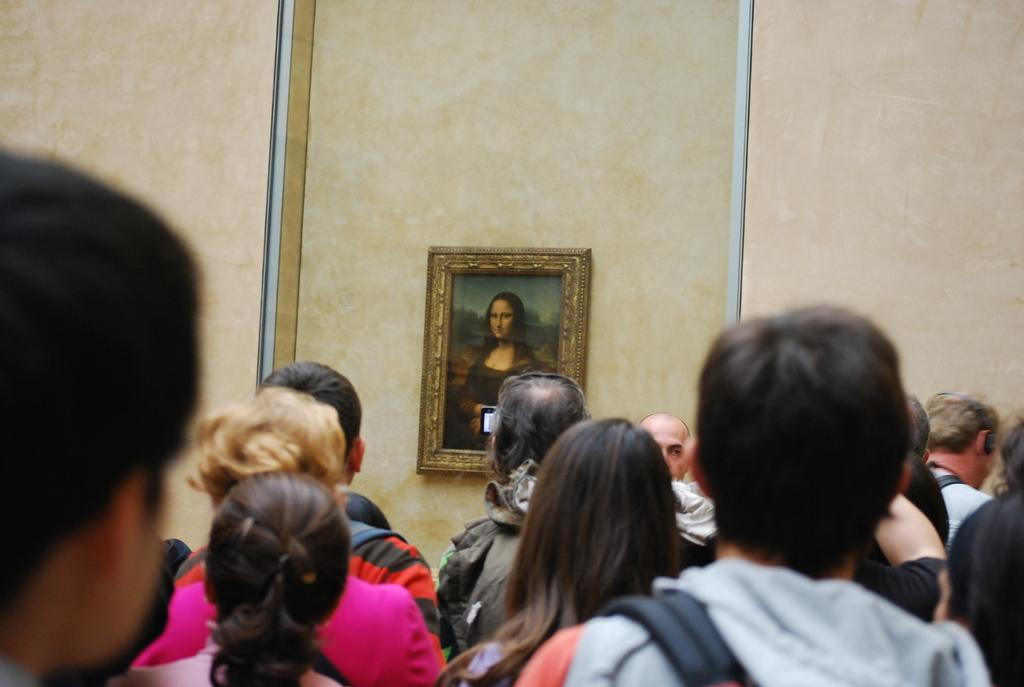How many people are in the image? There are people standing in the image. What are the people looking at? The people are looking at a wall. What is on the wall that the people are looking at? There is a photo frame on the wall. What painting is inside the photo frame? The photo frame contains a Monalisa painting. What type of plastic material is used to create the canvas for the Monalisa painting in the image? The Monalisa painting is not on a canvas, and there is no mention of plastic material in the image. 